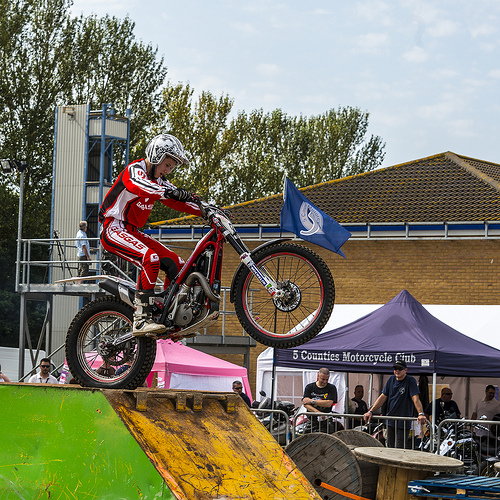<image>
Is the wheel on the roof? No. The wheel is not positioned on the roof. They may be near each other, but the wheel is not supported by or resting on top of the roof. 